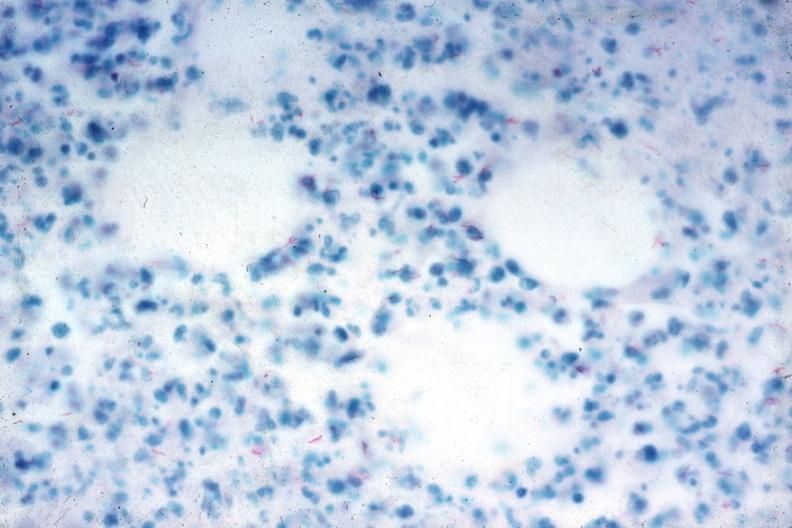s acute peritonitis present?
Answer the question using a single word or phrase. No 